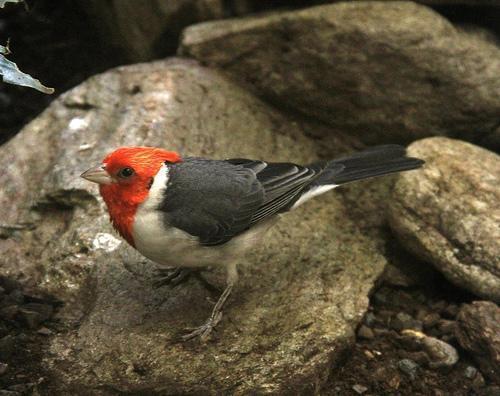How many birds are in the picture?
Give a very brief answer. 1. How many feet this bird has?
Give a very brief answer. 2. How many claws on a bird's foot?
Give a very brief answer. 4. How many wings does the bird have?
Give a very brief answer. 2. 